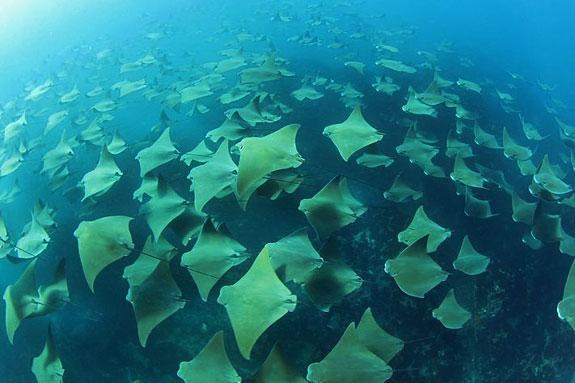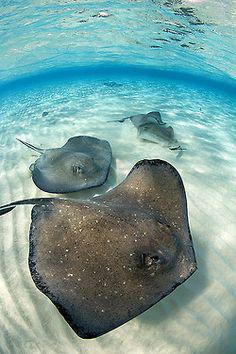The first image is the image on the left, the second image is the image on the right. Evaluate the accuracy of this statement regarding the images: "An image contains no more than three stingray in the foreground.". Is it true? Answer yes or no. Yes. 